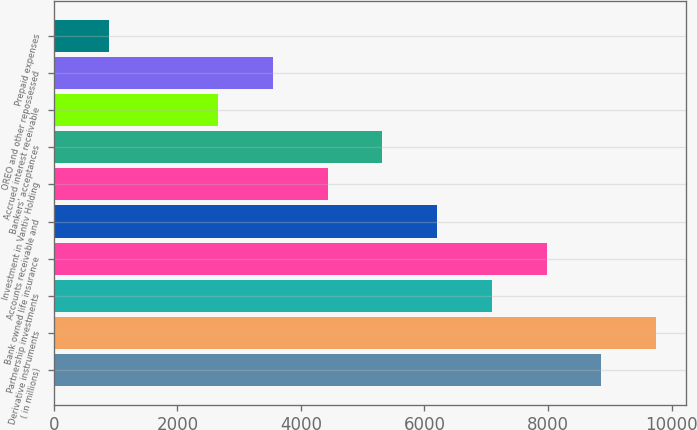Convert chart to OTSL. <chart><loc_0><loc_0><loc_500><loc_500><bar_chart><fcel>( in millions)<fcel>Derivative instruments<fcel>Partnership investments<fcel>Bank owned life insurance<fcel>Accounts receivable and<fcel>Investment in Vantiv Holding<fcel>Bankers' acceptances<fcel>Accrued interest receivable<fcel>OREO and other repossessed<fcel>Prepaid expenses<nl><fcel>8863<fcel>9748.8<fcel>7091.4<fcel>7977.2<fcel>6205.6<fcel>4434<fcel>5319.8<fcel>2662.4<fcel>3548.2<fcel>890.8<nl></chart> 